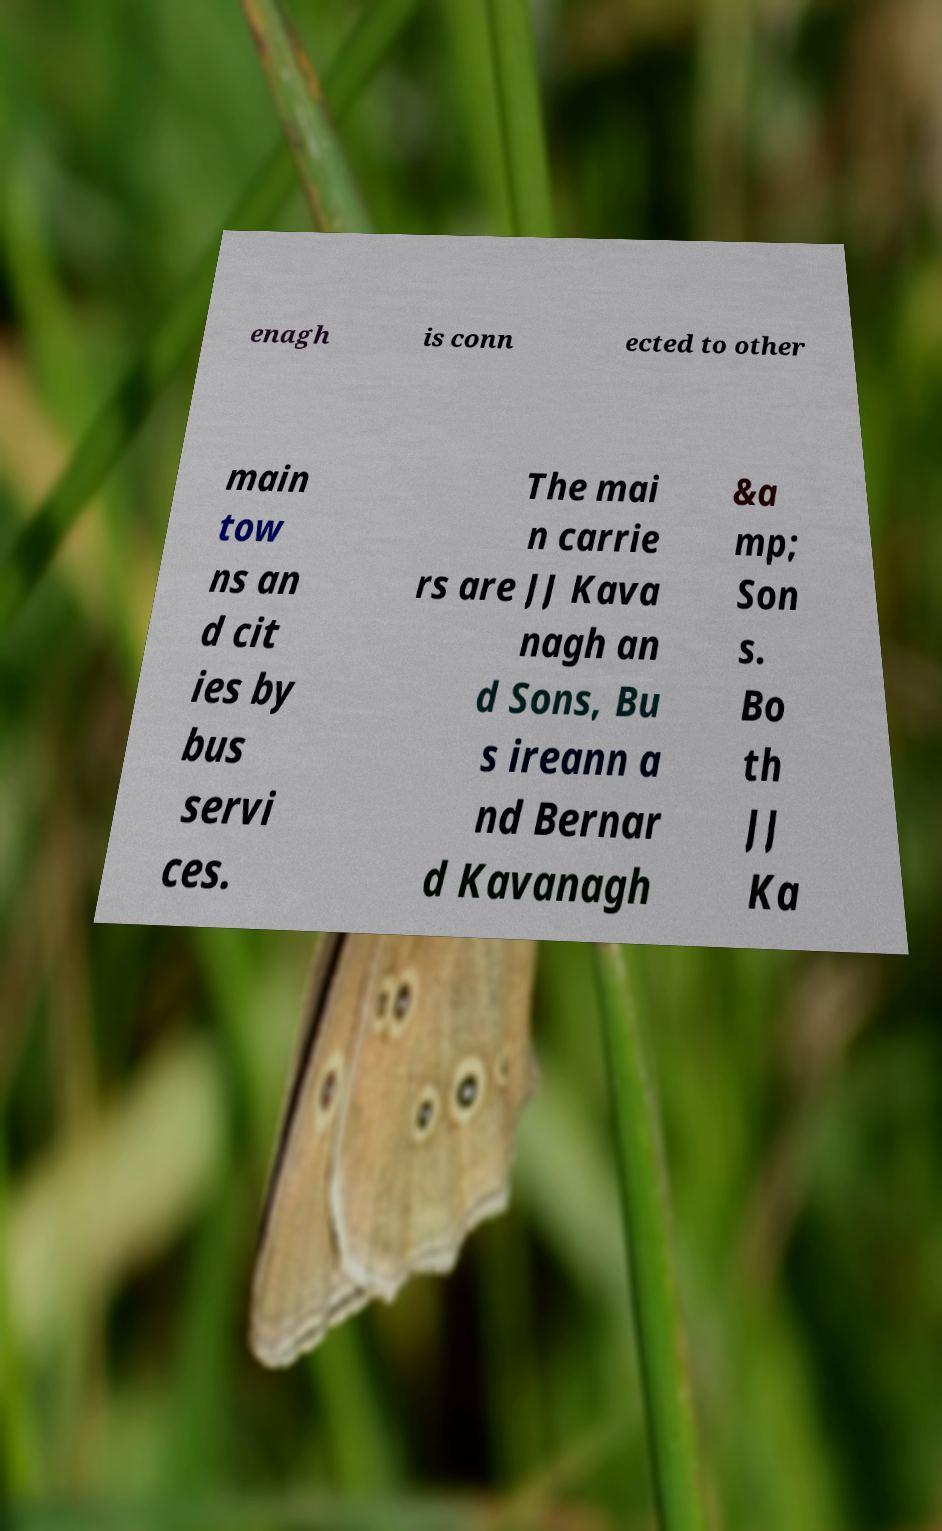Could you assist in decoding the text presented in this image and type it out clearly? enagh is conn ected to other main tow ns an d cit ies by bus servi ces. The mai n carrie rs are JJ Kava nagh an d Sons, Bu s ireann a nd Bernar d Kavanagh &a mp; Son s. Bo th JJ Ka 